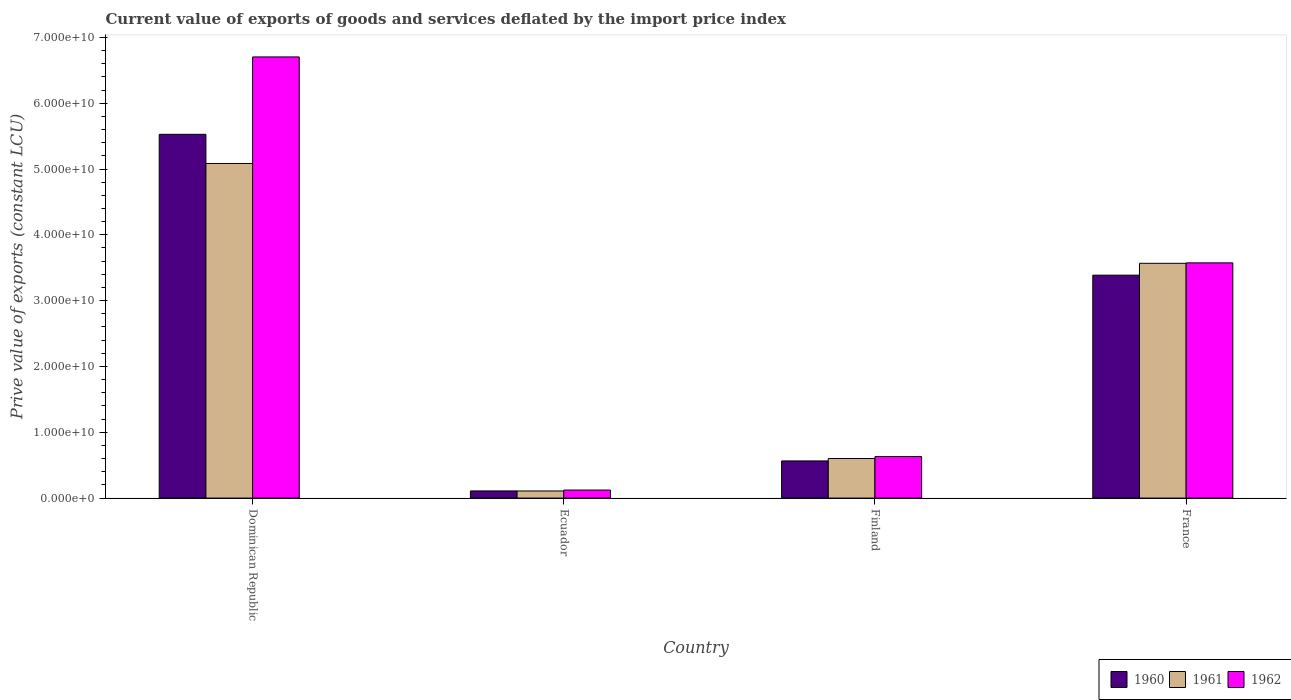How many bars are there on the 3rd tick from the right?
Ensure brevity in your answer.  3. What is the label of the 1st group of bars from the left?
Give a very brief answer. Dominican Republic. In how many cases, is the number of bars for a given country not equal to the number of legend labels?
Offer a terse response. 0. What is the prive value of exports in 1961 in Finland?
Your answer should be very brief. 6.02e+09. Across all countries, what is the maximum prive value of exports in 1962?
Give a very brief answer. 6.70e+1. Across all countries, what is the minimum prive value of exports in 1960?
Your answer should be compact. 1.09e+09. In which country was the prive value of exports in 1962 maximum?
Your answer should be very brief. Dominican Republic. In which country was the prive value of exports in 1962 minimum?
Offer a very short reply. Ecuador. What is the total prive value of exports in 1960 in the graph?
Provide a short and direct response. 9.59e+1. What is the difference between the prive value of exports in 1962 in Ecuador and that in Finland?
Keep it short and to the point. -5.09e+09. What is the difference between the prive value of exports in 1960 in France and the prive value of exports in 1962 in Dominican Republic?
Your answer should be very brief. -3.32e+1. What is the average prive value of exports in 1960 per country?
Your answer should be very brief. 2.40e+1. What is the difference between the prive value of exports of/in 1960 and prive value of exports of/in 1962 in Ecuador?
Offer a very short reply. -1.34e+08. In how many countries, is the prive value of exports in 1962 greater than 62000000000 LCU?
Make the answer very short. 1. What is the ratio of the prive value of exports in 1961 in Ecuador to that in Finland?
Give a very brief answer. 0.18. What is the difference between the highest and the second highest prive value of exports in 1960?
Provide a short and direct response. -4.96e+1. What is the difference between the highest and the lowest prive value of exports in 1960?
Provide a short and direct response. 5.42e+1. In how many countries, is the prive value of exports in 1961 greater than the average prive value of exports in 1961 taken over all countries?
Ensure brevity in your answer.  2. Is the sum of the prive value of exports in 1961 in Ecuador and France greater than the maximum prive value of exports in 1960 across all countries?
Provide a short and direct response. No. What does the 3rd bar from the left in France represents?
Give a very brief answer. 1962. What does the 3rd bar from the right in Dominican Republic represents?
Your answer should be compact. 1960. How many bars are there?
Give a very brief answer. 12. Are the values on the major ticks of Y-axis written in scientific E-notation?
Your answer should be very brief. Yes. Does the graph contain any zero values?
Provide a short and direct response. No. What is the title of the graph?
Your response must be concise. Current value of exports of goods and services deflated by the import price index. What is the label or title of the Y-axis?
Offer a terse response. Prive value of exports (constant LCU). What is the Prive value of exports (constant LCU) of 1960 in Dominican Republic?
Offer a very short reply. 5.53e+1. What is the Prive value of exports (constant LCU) in 1961 in Dominican Republic?
Your answer should be compact. 5.08e+1. What is the Prive value of exports (constant LCU) in 1962 in Dominican Republic?
Offer a very short reply. 6.70e+1. What is the Prive value of exports (constant LCU) of 1960 in Ecuador?
Your answer should be very brief. 1.09e+09. What is the Prive value of exports (constant LCU) in 1961 in Ecuador?
Your response must be concise. 1.08e+09. What is the Prive value of exports (constant LCU) of 1962 in Ecuador?
Provide a succinct answer. 1.22e+09. What is the Prive value of exports (constant LCU) of 1960 in Finland?
Ensure brevity in your answer.  5.65e+09. What is the Prive value of exports (constant LCU) in 1961 in Finland?
Provide a short and direct response. 6.02e+09. What is the Prive value of exports (constant LCU) in 1962 in Finland?
Your answer should be compact. 6.31e+09. What is the Prive value of exports (constant LCU) in 1960 in France?
Make the answer very short. 3.39e+1. What is the Prive value of exports (constant LCU) in 1961 in France?
Offer a terse response. 3.57e+1. What is the Prive value of exports (constant LCU) in 1962 in France?
Ensure brevity in your answer.  3.57e+1. Across all countries, what is the maximum Prive value of exports (constant LCU) of 1960?
Your answer should be compact. 5.53e+1. Across all countries, what is the maximum Prive value of exports (constant LCU) in 1961?
Provide a succinct answer. 5.08e+1. Across all countries, what is the maximum Prive value of exports (constant LCU) in 1962?
Provide a succinct answer. 6.70e+1. Across all countries, what is the minimum Prive value of exports (constant LCU) of 1960?
Your answer should be very brief. 1.09e+09. Across all countries, what is the minimum Prive value of exports (constant LCU) in 1961?
Offer a terse response. 1.08e+09. Across all countries, what is the minimum Prive value of exports (constant LCU) in 1962?
Ensure brevity in your answer.  1.22e+09. What is the total Prive value of exports (constant LCU) in 1960 in the graph?
Your answer should be compact. 9.59e+1. What is the total Prive value of exports (constant LCU) in 1961 in the graph?
Provide a succinct answer. 9.36e+1. What is the total Prive value of exports (constant LCU) in 1962 in the graph?
Your answer should be compact. 1.10e+11. What is the difference between the Prive value of exports (constant LCU) of 1960 in Dominican Republic and that in Ecuador?
Your answer should be very brief. 5.42e+1. What is the difference between the Prive value of exports (constant LCU) in 1961 in Dominican Republic and that in Ecuador?
Give a very brief answer. 4.98e+1. What is the difference between the Prive value of exports (constant LCU) of 1962 in Dominican Republic and that in Ecuador?
Ensure brevity in your answer.  6.58e+1. What is the difference between the Prive value of exports (constant LCU) in 1960 in Dominican Republic and that in Finland?
Offer a terse response. 4.96e+1. What is the difference between the Prive value of exports (constant LCU) of 1961 in Dominican Republic and that in Finland?
Make the answer very short. 4.48e+1. What is the difference between the Prive value of exports (constant LCU) of 1962 in Dominican Republic and that in Finland?
Ensure brevity in your answer.  6.07e+1. What is the difference between the Prive value of exports (constant LCU) in 1960 in Dominican Republic and that in France?
Keep it short and to the point. 2.14e+1. What is the difference between the Prive value of exports (constant LCU) in 1961 in Dominican Republic and that in France?
Your response must be concise. 1.52e+1. What is the difference between the Prive value of exports (constant LCU) of 1962 in Dominican Republic and that in France?
Provide a short and direct response. 3.13e+1. What is the difference between the Prive value of exports (constant LCU) of 1960 in Ecuador and that in Finland?
Ensure brevity in your answer.  -4.56e+09. What is the difference between the Prive value of exports (constant LCU) in 1961 in Ecuador and that in Finland?
Keep it short and to the point. -4.94e+09. What is the difference between the Prive value of exports (constant LCU) of 1962 in Ecuador and that in Finland?
Offer a terse response. -5.09e+09. What is the difference between the Prive value of exports (constant LCU) of 1960 in Ecuador and that in France?
Provide a short and direct response. -3.28e+1. What is the difference between the Prive value of exports (constant LCU) of 1961 in Ecuador and that in France?
Give a very brief answer. -3.46e+1. What is the difference between the Prive value of exports (constant LCU) in 1962 in Ecuador and that in France?
Provide a short and direct response. -3.45e+1. What is the difference between the Prive value of exports (constant LCU) in 1960 in Finland and that in France?
Make the answer very short. -2.82e+1. What is the difference between the Prive value of exports (constant LCU) of 1961 in Finland and that in France?
Provide a succinct answer. -2.97e+1. What is the difference between the Prive value of exports (constant LCU) in 1962 in Finland and that in France?
Your answer should be compact. -2.94e+1. What is the difference between the Prive value of exports (constant LCU) in 1960 in Dominican Republic and the Prive value of exports (constant LCU) in 1961 in Ecuador?
Give a very brief answer. 5.42e+1. What is the difference between the Prive value of exports (constant LCU) of 1960 in Dominican Republic and the Prive value of exports (constant LCU) of 1962 in Ecuador?
Provide a succinct answer. 5.40e+1. What is the difference between the Prive value of exports (constant LCU) in 1961 in Dominican Republic and the Prive value of exports (constant LCU) in 1962 in Ecuador?
Your answer should be very brief. 4.96e+1. What is the difference between the Prive value of exports (constant LCU) in 1960 in Dominican Republic and the Prive value of exports (constant LCU) in 1961 in Finland?
Give a very brief answer. 4.93e+1. What is the difference between the Prive value of exports (constant LCU) in 1960 in Dominican Republic and the Prive value of exports (constant LCU) in 1962 in Finland?
Provide a succinct answer. 4.90e+1. What is the difference between the Prive value of exports (constant LCU) in 1961 in Dominican Republic and the Prive value of exports (constant LCU) in 1962 in Finland?
Your response must be concise. 4.45e+1. What is the difference between the Prive value of exports (constant LCU) of 1960 in Dominican Republic and the Prive value of exports (constant LCU) of 1961 in France?
Ensure brevity in your answer.  1.96e+1. What is the difference between the Prive value of exports (constant LCU) in 1960 in Dominican Republic and the Prive value of exports (constant LCU) in 1962 in France?
Provide a short and direct response. 1.95e+1. What is the difference between the Prive value of exports (constant LCU) in 1961 in Dominican Republic and the Prive value of exports (constant LCU) in 1962 in France?
Keep it short and to the point. 1.51e+1. What is the difference between the Prive value of exports (constant LCU) in 1960 in Ecuador and the Prive value of exports (constant LCU) in 1961 in Finland?
Your answer should be compact. -4.93e+09. What is the difference between the Prive value of exports (constant LCU) in 1960 in Ecuador and the Prive value of exports (constant LCU) in 1962 in Finland?
Offer a terse response. -5.22e+09. What is the difference between the Prive value of exports (constant LCU) of 1961 in Ecuador and the Prive value of exports (constant LCU) of 1962 in Finland?
Offer a terse response. -5.23e+09. What is the difference between the Prive value of exports (constant LCU) in 1960 in Ecuador and the Prive value of exports (constant LCU) in 1961 in France?
Offer a very short reply. -3.46e+1. What is the difference between the Prive value of exports (constant LCU) of 1960 in Ecuador and the Prive value of exports (constant LCU) of 1962 in France?
Your answer should be compact. -3.47e+1. What is the difference between the Prive value of exports (constant LCU) of 1961 in Ecuador and the Prive value of exports (constant LCU) of 1962 in France?
Provide a succinct answer. -3.47e+1. What is the difference between the Prive value of exports (constant LCU) of 1960 in Finland and the Prive value of exports (constant LCU) of 1961 in France?
Your answer should be very brief. -3.00e+1. What is the difference between the Prive value of exports (constant LCU) in 1960 in Finland and the Prive value of exports (constant LCU) in 1962 in France?
Offer a terse response. -3.01e+1. What is the difference between the Prive value of exports (constant LCU) in 1961 in Finland and the Prive value of exports (constant LCU) in 1962 in France?
Your answer should be very brief. -2.97e+1. What is the average Prive value of exports (constant LCU) in 1960 per country?
Your answer should be very brief. 2.40e+1. What is the average Prive value of exports (constant LCU) in 1961 per country?
Ensure brevity in your answer.  2.34e+1. What is the average Prive value of exports (constant LCU) of 1962 per country?
Provide a succinct answer. 2.76e+1. What is the difference between the Prive value of exports (constant LCU) of 1960 and Prive value of exports (constant LCU) of 1961 in Dominican Republic?
Ensure brevity in your answer.  4.43e+09. What is the difference between the Prive value of exports (constant LCU) in 1960 and Prive value of exports (constant LCU) in 1962 in Dominican Republic?
Offer a terse response. -1.18e+1. What is the difference between the Prive value of exports (constant LCU) in 1961 and Prive value of exports (constant LCU) in 1962 in Dominican Republic?
Make the answer very short. -1.62e+1. What is the difference between the Prive value of exports (constant LCU) in 1960 and Prive value of exports (constant LCU) in 1961 in Ecuador?
Your answer should be very brief. 7.73e+06. What is the difference between the Prive value of exports (constant LCU) of 1960 and Prive value of exports (constant LCU) of 1962 in Ecuador?
Your response must be concise. -1.34e+08. What is the difference between the Prive value of exports (constant LCU) in 1961 and Prive value of exports (constant LCU) in 1962 in Ecuador?
Offer a very short reply. -1.41e+08. What is the difference between the Prive value of exports (constant LCU) of 1960 and Prive value of exports (constant LCU) of 1961 in Finland?
Provide a succinct answer. -3.69e+08. What is the difference between the Prive value of exports (constant LCU) in 1960 and Prive value of exports (constant LCU) in 1962 in Finland?
Your response must be concise. -6.62e+08. What is the difference between the Prive value of exports (constant LCU) of 1961 and Prive value of exports (constant LCU) of 1962 in Finland?
Provide a short and direct response. -2.93e+08. What is the difference between the Prive value of exports (constant LCU) of 1960 and Prive value of exports (constant LCU) of 1961 in France?
Your answer should be very brief. -1.80e+09. What is the difference between the Prive value of exports (constant LCU) in 1960 and Prive value of exports (constant LCU) in 1962 in France?
Your answer should be compact. -1.87e+09. What is the difference between the Prive value of exports (constant LCU) in 1961 and Prive value of exports (constant LCU) in 1962 in France?
Give a very brief answer. -6.74e+07. What is the ratio of the Prive value of exports (constant LCU) of 1960 in Dominican Republic to that in Ecuador?
Your response must be concise. 50.79. What is the ratio of the Prive value of exports (constant LCU) of 1961 in Dominican Republic to that in Ecuador?
Keep it short and to the point. 47.06. What is the ratio of the Prive value of exports (constant LCU) in 1962 in Dominican Republic to that in Ecuador?
Your response must be concise. 54.86. What is the ratio of the Prive value of exports (constant LCU) of 1960 in Dominican Republic to that in Finland?
Keep it short and to the point. 9.79. What is the ratio of the Prive value of exports (constant LCU) in 1961 in Dominican Republic to that in Finland?
Give a very brief answer. 8.45. What is the ratio of the Prive value of exports (constant LCU) of 1962 in Dominican Republic to that in Finland?
Provide a succinct answer. 10.62. What is the ratio of the Prive value of exports (constant LCU) of 1960 in Dominican Republic to that in France?
Keep it short and to the point. 1.63. What is the ratio of the Prive value of exports (constant LCU) of 1961 in Dominican Republic to that in France?
Ensure brevity in your answer.  1.43. What is the ratio of the Prive value of exports (constant LCU) of 1962 in Dominican Republic to that in France?
Your response must be concise. 1.88. What is the ratio of the Prive value of exports (constant LCU) in 1960 in Ecuador to that in Finland?
Ensure brevity in your answer.  0.19. What is the ratio of the Prive value of exports (constant LCU) of 1961 in Ecuador to that in Finland?
Your answer should be very brief. 0.18. What is the ratio of the Prive value of exports (constant LCU) of 1962 in Ecuador to that in Finland?
Ensure brevity in your answer.  0.19. What is the ratio of the Prive value of exports (constant LCU) of 1960 in Ecuador to that in France?
Keep it short and to the point. 0.03. What is the ratio of the Prive value of exports (constant LCU) in 1961 in Ecuador to that in France?
Your answer should be very brief. 0.03. What is the ratio of the Prive value of exports (constant LCU) of 1962 in Ecuador to that in France?
Make the answer very short. 0.03. What is the ratio of the Prive value of exports (constant LCU) in 1960 in Finland to that in France?
Provide a short and direct response. 0.17. What is the ratio of the Prive value of exports (constant LCU) in 1961 in Finland to that in France?
Keep it short and to the point. 0.17. What is the ratio of the Prive value of exports (constant LCU) of 1962 in Finland to that in France?
Give a very brief answer. 0.18. What is the difference between the highest and the second highest Prive value of exports (constant LCU) of 1960?
Offer a terse response. 2.14e+1. What is the difference between the highest and the second highest Prive value of exports (constant LCU) of 1961?
Give a very brief answer. 1.52e+1. What is the difference between the highest and the second highest Prive value of exports (constant LCU) of 1962?
Provide a succinct answer. 3.13e+1. What is the difference between the highest and the lowest Prive value of exports (constant LCU) in 1960?
Your answer should be compact. 5.42e+1. What is the difference between the highest and the lowest Prive value of exports (constant LCU) in 1961?
Your response must be concise. 4.98e+1. What is the difference between the highest and the lowest Prive value of exports (constant LCU) in 1962?
Your response must be concise. 6.58e+1. 